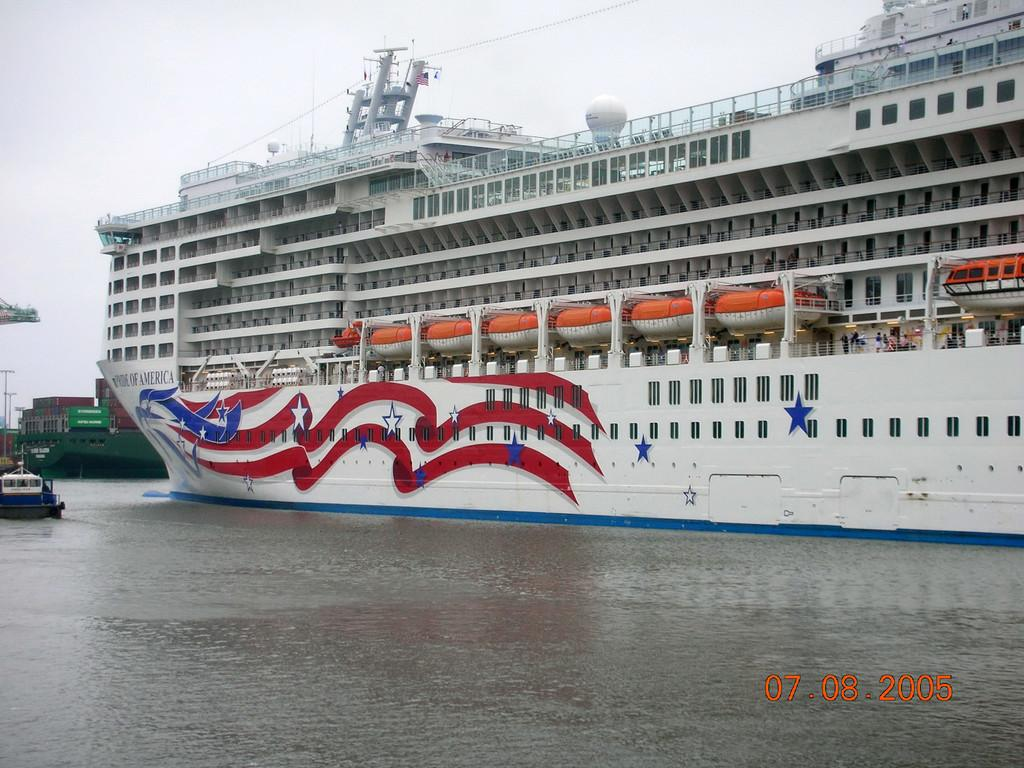What is the main subject of the image? The main subject of the image is ships. Where are the ships located? The ships are on the water. What type of support can be seen for the ships in the image? There is no visible support for the ships in the image; they are floating on the water. Who is the expert on the ships in the image? There is no indication of an expert on the ships in the image. 